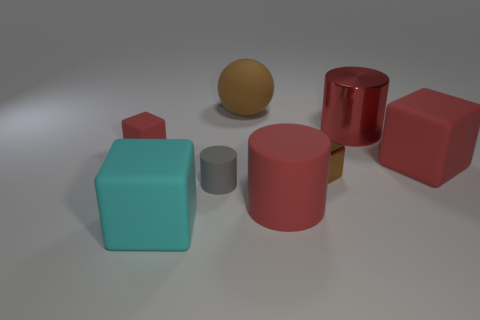Subtract all blue balls. How many red cylinders are left? 2 Add 1 big red shiny objects. How many objects exist? 9 Subtract all matte blocks. How many blocks are left? 1 Subtract 2 blocks. How many blocks are left? 2 Subtract all cyan cubes. How many cubes are left? 3 Subtract all balls. How many objects are left? 7 Subtract all blue cylinders. Subtract all red cubes. How many cylinders are left? 3 Subtract all large red shiny things. Subtract all red rubber objects. How many objects are left? 4 Add 5 red cylinders. How many red cylinders are left? 7 Add 3 cyan rubber objects. How many cyan rubber objects exist? 4 